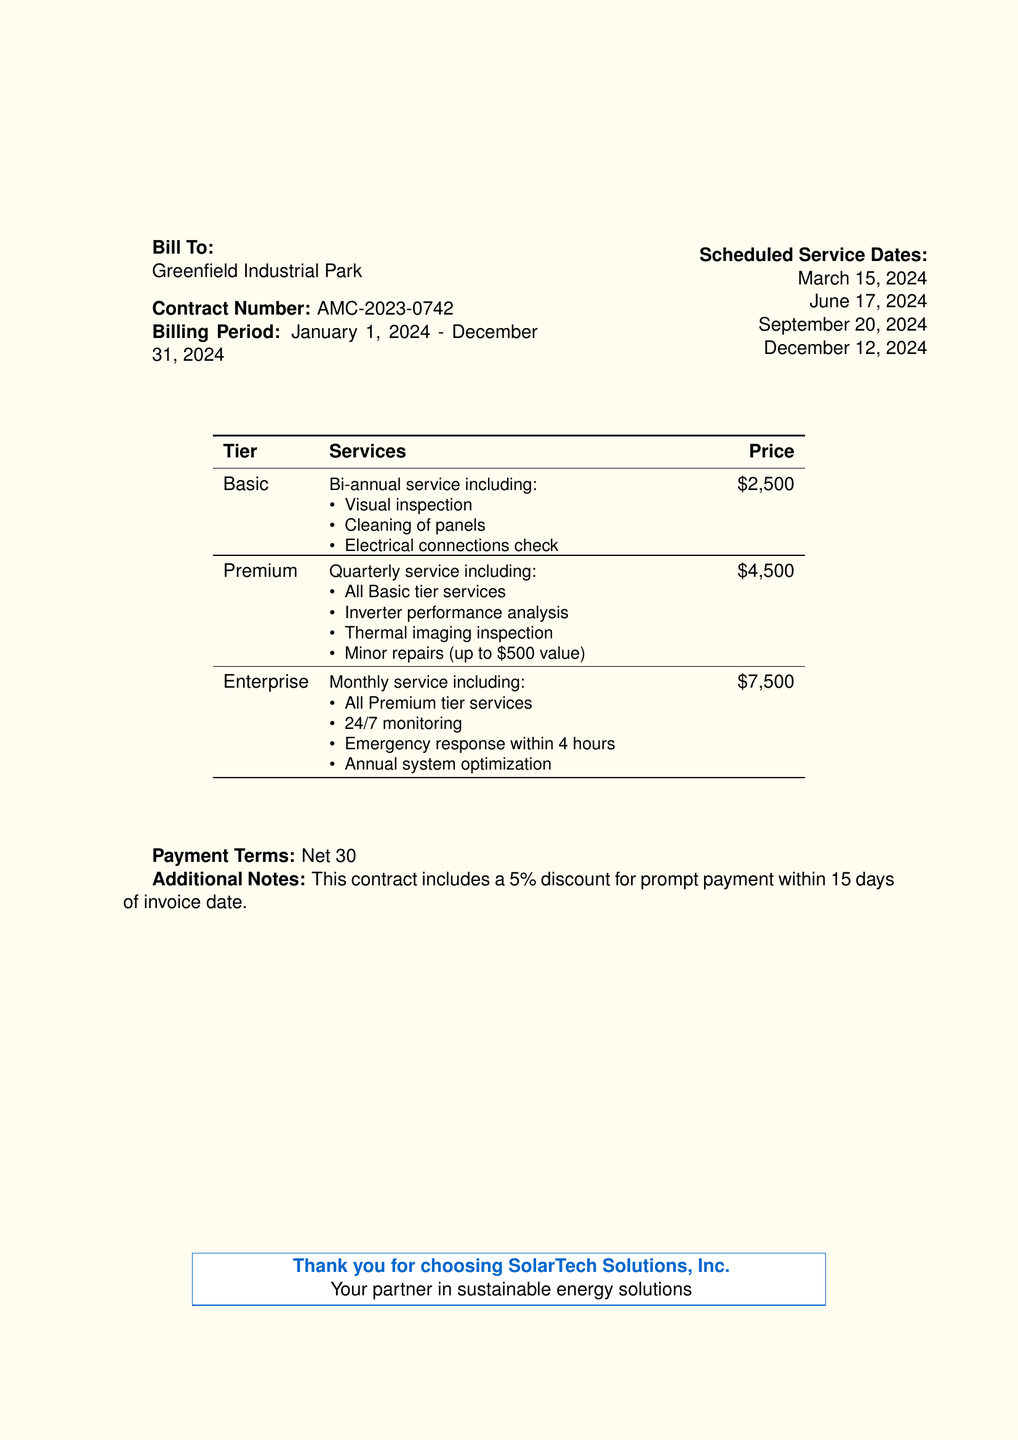what is the contract number? The contract number is explicitly mentioned in the bill section, which is AMC-2023-0742.
Answer: AMC-2023-0742 what is the billing period? The billing period indicates the start and end date of the contract, which is January 1, 2024 to December 31, 2024.
Answer: January 1, 2024 - December 31, 2024 how many scheduled service dates are listed? The document states four scheduled service dates for the year, which is counted from the list provided.
Answer: 4 what services are included in the Premium tier? The Premium tier includes several specific services that build upon the Basic tier; these services are listed collectively.
Answer: All Basic tier services, Inverter performance analysis, Thermal imaging inspection, Minor repairs (up to $500 value) what is the price for the Basic tier? The price for the Basic tier is stated as a specific amount in the pricing table.
Answer: $2,500 what is the discount for prompt payment? The discount for making a payment within a specific time frame after the invoice date is clearly stated.
Answer: 5% what is the emergency response time for the Enterprise tier? The document specifies the response time for emergencies under the Enterprise tier requirement.
Answer: 4 hours how often are services performed for the Enterprise tier? The frequency of services for the Enterprise tier is stated in the description of that tier.
Answer: Monthly 